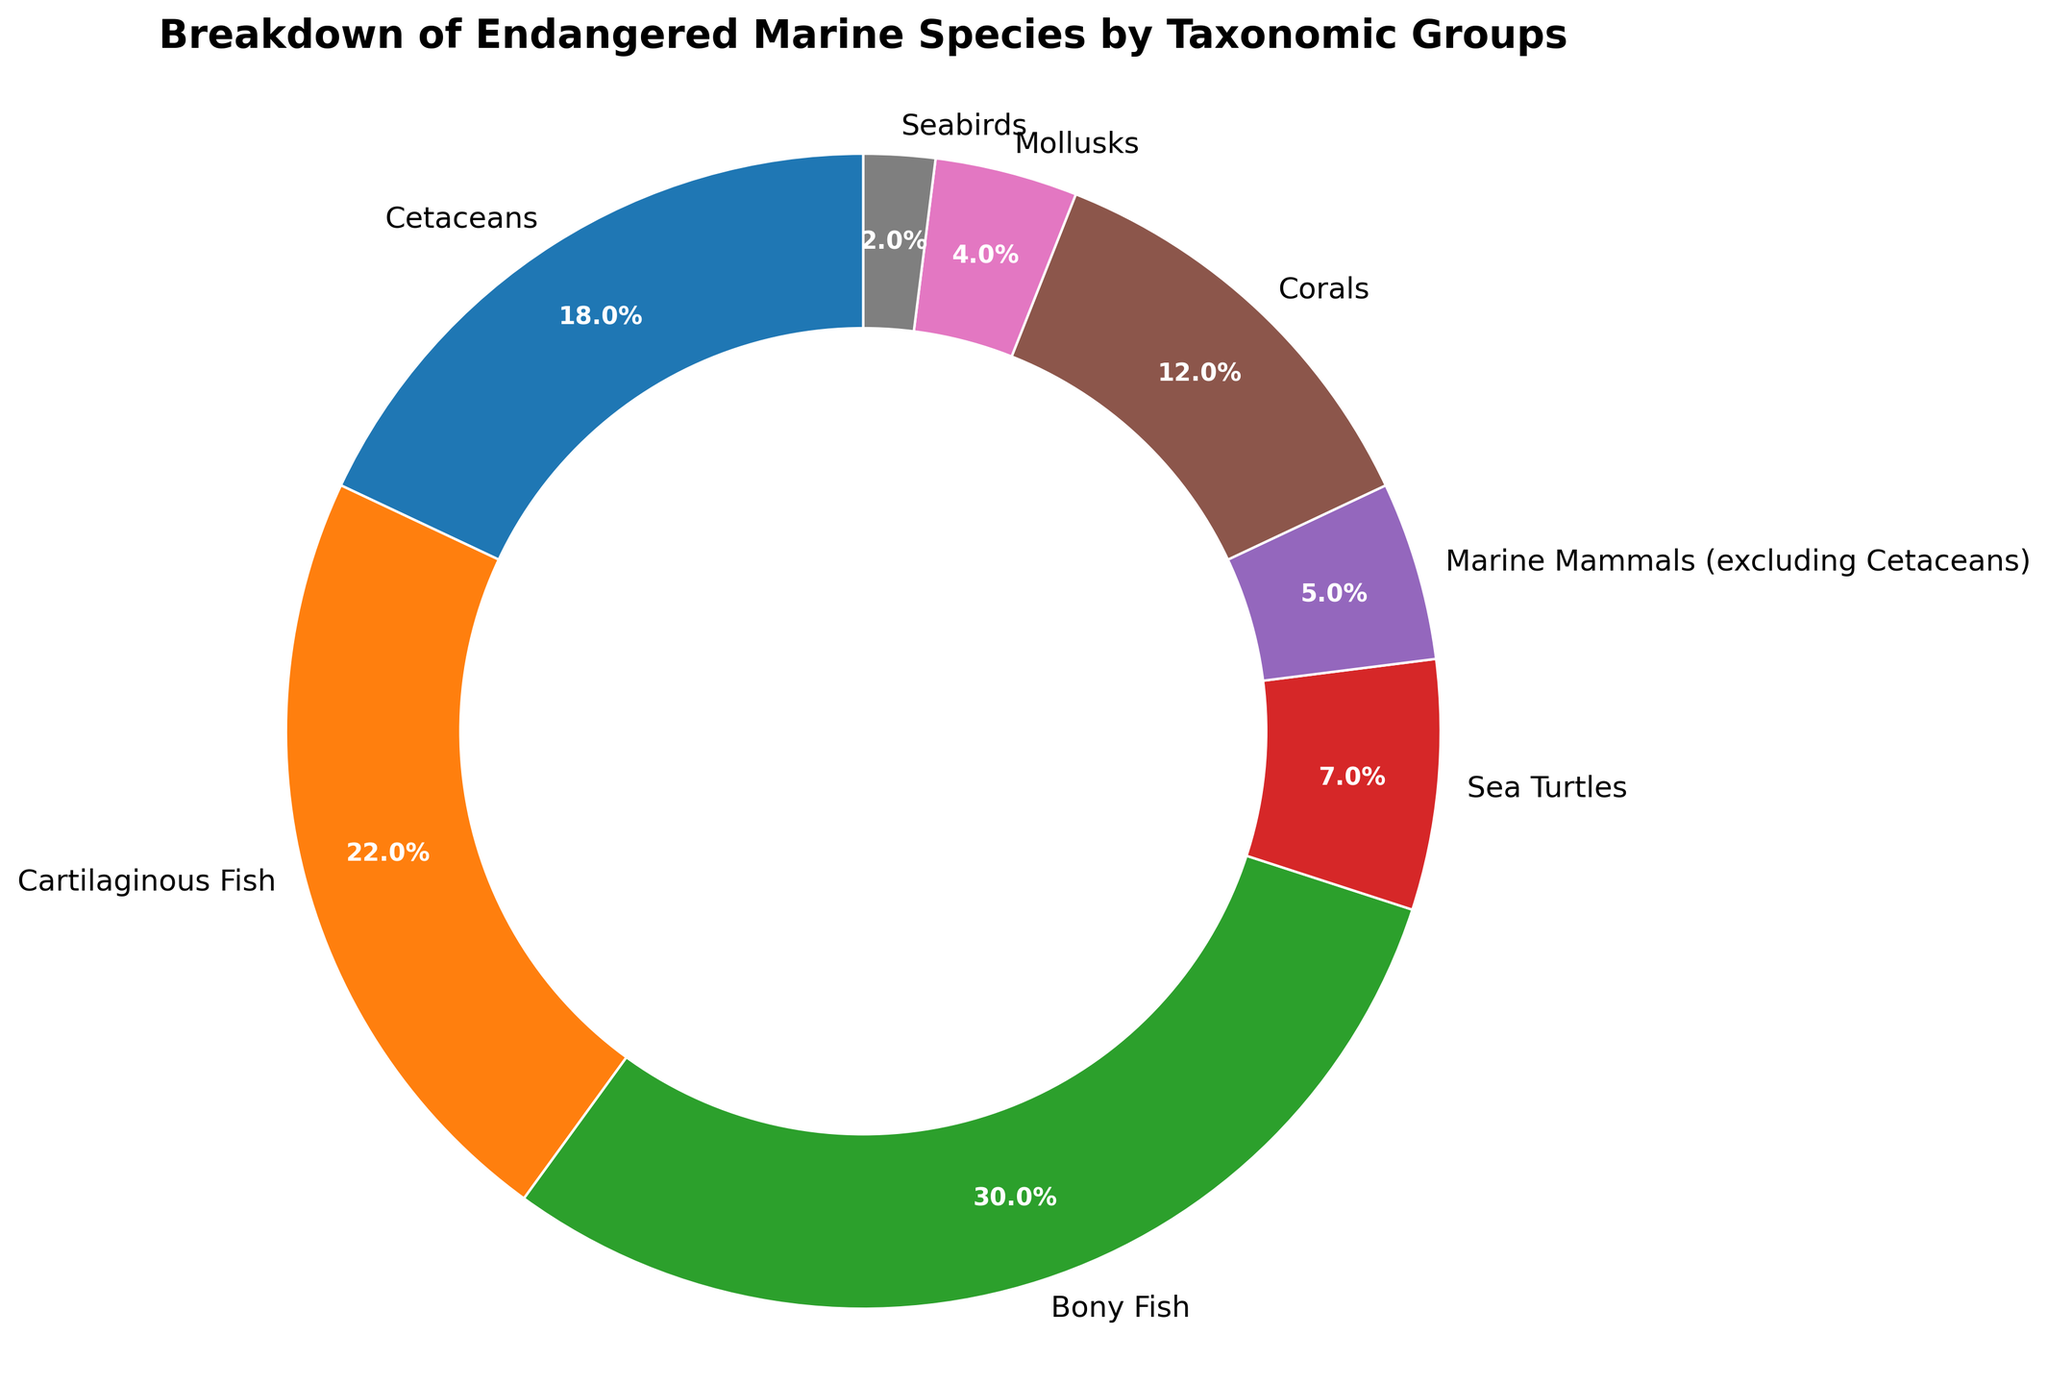What percentage of endangered marine species are bony fish? The pie chart shows the proportion of endangered species by taxonomic group. Locate the "Bony Fish" section and read its percentage.
Answer: 30% Which taxonomic group has the smallest percentage of endangered species? Inspect all sections of the pie chart and identify the group with the smallest percentage.
Answer: Seabirds How do the percentages of cetaceans and marine mammals (excluding cetaceans) compare? Locate the percentages of cetaceans and marine mammals on the chart and compare them.
Answer: Cetaceans are higher What is the combined percentage of endangered sea turtles and mollusks? Find the percentages for sea turtles and mollusks, then add them together: 7% (sea turtles) + 4% (mollusks) = 11%
Answer: 11% Which color represents cartilaginous fish on the chart? Identify the section labeled "Cartilaginous Fish" and observe its color.
Answer: Orange Are corals or cetaceans more prevalent among the endangered species? Compare the percentages shown for corals and cetaceans.
Answer: Cetaceans What is the difference in percentage between cartilaginous fish and bony fish? Subtract the percentage of cartilaginous fish from that of bony fish: 30% (bony fish) - 22% (cartilaginous fish) = 8%
Answer: 8% What fraction of the pie chart does marine mammals (excluding cetaceans) cover? Convert the percentage of marine mammals (excluding cetaceans) into a decimal: 5% is 5/100 = 0.05.
Answer: 0.05 Which two groups together make up half of the endangered species? Identify the two group's percentages that sum to around 50%. Sum 30% (bony fish) and 22% (cartilaginous fish) to get 52%.
Answer: Bony fish and cartilaginous fish What is the ratio of seabirds to the total endangered species? Read the percentage of seabirds, 2%. Convert it to a decimal (2/100 = 0.02) and express it as a ratio.
Answer: 1:50 